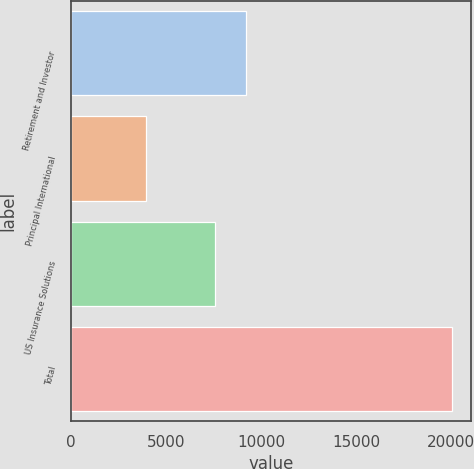Convert chart to OTSL. <chart><loc_0><loc_0><loc_500><loc_500><bar_chart><fcel>Retirement and Investor<fcel>Principal International<fcel>US Insurance Solutions<fcel>Total<nl><fcel>9194.1<fcel>3969.3<fcel>7586.4<fcel>20046.3<nl></chart> 